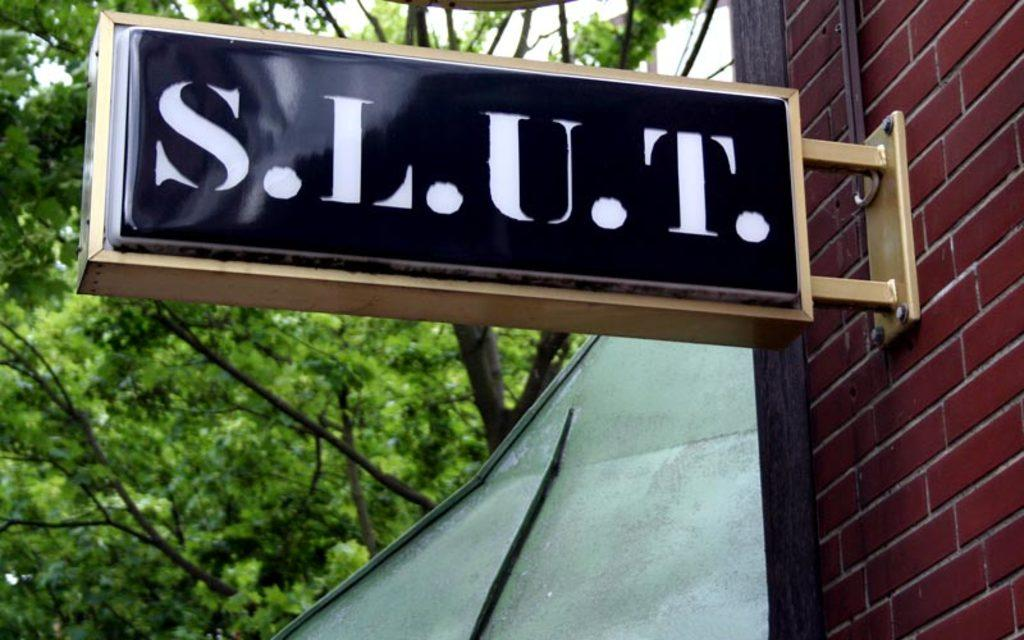What type of structure is on the right side of the image? There is a brick wall on the right side of the image. What is attached to the brick wall? A board is attached to the wall. What can be seen on the board? Something is written on the board. What can be seen in the distance in the image? There are trees in the background of the image. What day of the week is depicted in the image? The day of the week is not depicted in the image; it only shows a brick wall, a board, and trees in the background. 